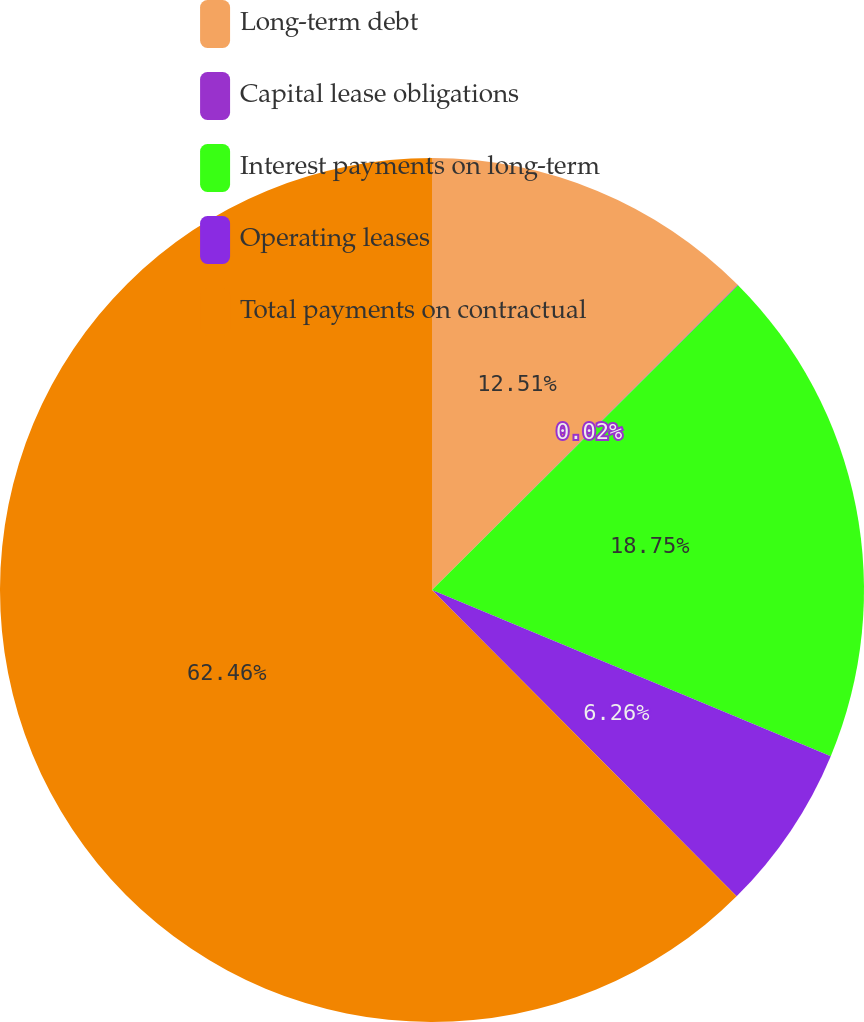<chart> <loc_0><loc_0><loc_500><loc_500><pie_chart><fcel>Long-term debt<fcel>Capital lease obligations<fcel>Interest payments on long-term<fcel>Operating leases<fcel>Total payments on contractual<nl><fcel>12.51%<fcel>0.02%<fcel>18.75%<fcel>6.26%<fcel>62.45%<nl></chart> 